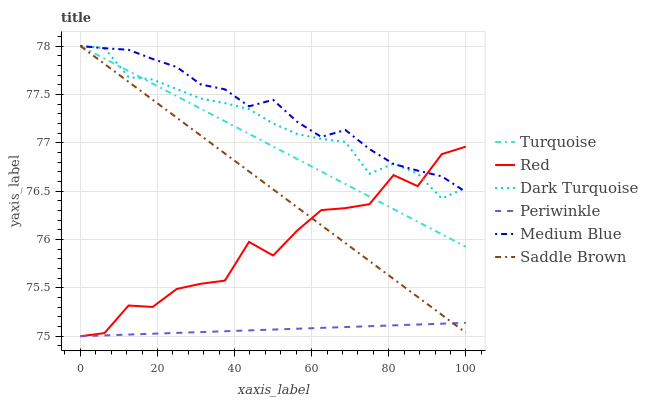Does Periwinkle have the minimum area under the curve?
Answer yes or no. Yes. Does Medium Blue have the maximum area under the curve?
Answer yes or no. Yes. Does Dark Turquoise have the minimum area under the curve?
Answer yes or no. No. Does Dark Turquoise have the maximum area under the curve?
Answer yes or no. No. Is Saddle Brown the smoothest?
Answer yes or no. Yes. Is Red the roughest?
Answer yes or no. Yes. Is Dark Turquoise the smoothest?
Answer yes or no. No. Is Dark Turquoise the roughest?
Answer yes or no. No. Does Periwinkle have the lowest value?
Answer yes or no. Yes. Does Dark Turquoise have the lowest value?
Answer yes or no. No. Does Saddle Brown have the highest value?
Answer yes or no. Yes. Does Periwinkle have the highest value?
Answer yes or no. No. Is Periwinkle less than Dark Turquoise?
Answer yes or no. Yes. Is Dark Turquoise greater than Periwinkle?
Answer yes or no. Yes. Does Turquoise intersect Red?
Answer yes or no. Yes. Is Turquoise less than Red?
Answer yes or no. No. Is Turquoise greater than Red?
Answer yes or no. No. Does Periwinkle intersect Dark Turquoise?
Answer yes or no. No. 